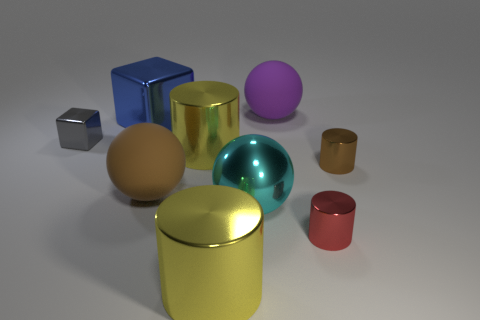What color is the small metallic thing on the left side of the big brown rubber thing?
Keep it short and to the point. Gray. There is a brown object to the left of the yellow object in front of the brown metallic cylinder; what is its material?
Ensure brevity in your answer.  Rubber. Are there any purple rubber objects that have the same size as the red cylinder?
Give a very brief answer. No. How many objects are either matte spheres on the left side of the purple object or cylinders right of the large cyan thing?
Offer a terse response. 3. There is a rubber object in front of the purple sphere; is it the same size as the yellow thing that is behind the cyan metallic thing?
Give a very brief answer. Yes. Are there any big purple rubber balls that are in front of the cube on the left side of the big blue shiny object?
Provide a short and direct response. No. There is a gray metallic cube; what number of rubber objects are in front of it?
Ensure brevity in your answer.  1. What number of other things are there of the same color as the large cube?
Provide a short and direct response. 0. Is the number of big blue blocks in front of the big brown matte ball less than the number of yellow cylinders behind the cyan object?
Give a very brief answer. Yes. What number of objects are big objects left of the purple matte object or red metallic cylinders?
Your response must be concise. 6. 